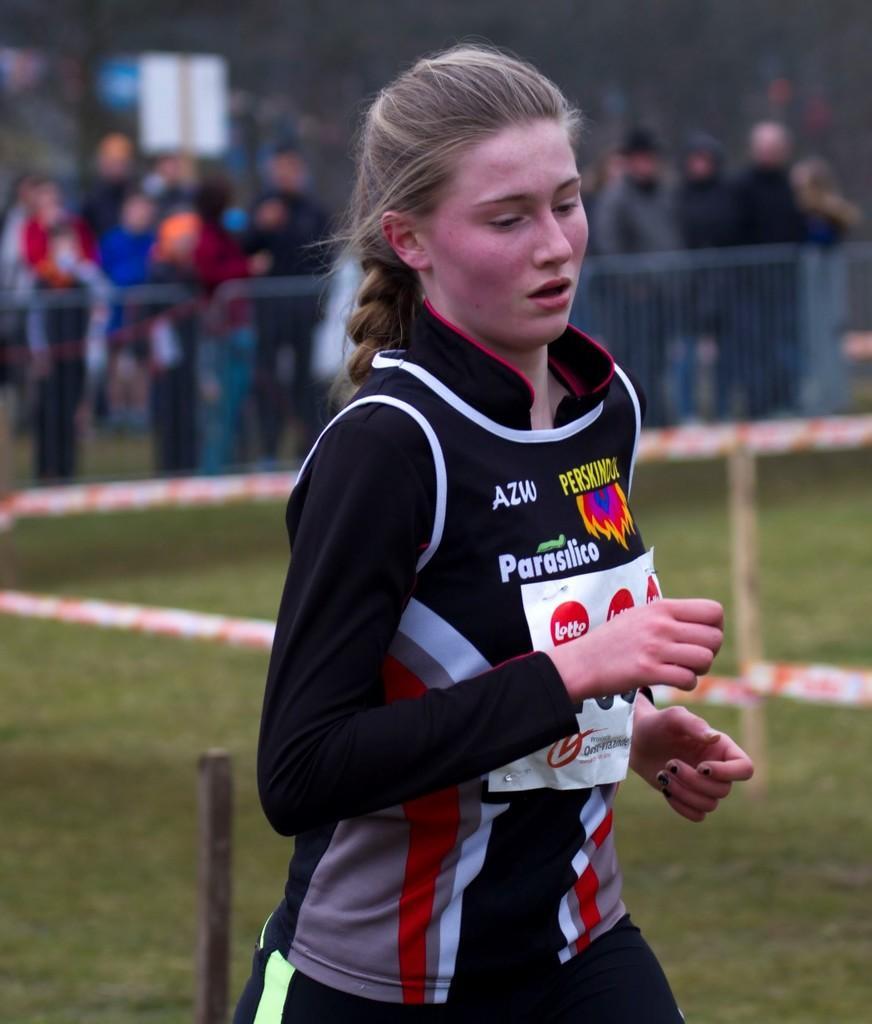Describe this image in one or two sentences. In this image I can see a woman in the front and I can see she is wearing black colour dress. I can also see a paper on her dress and on it I can see something is written. In the background I can see two poles, grass ground, few barrier tapes, iron fencing, a board and number of people. I can also see this image is little bit blurry in the background. 